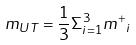<formula> <loc_0><loc_0><loc_500><loc_500>m _ { U T } = \frac { 1 } { 3 } \Sigma _ { i = 1 } ^ { 3 } { m ^ { + } } _ { i }</formula> 